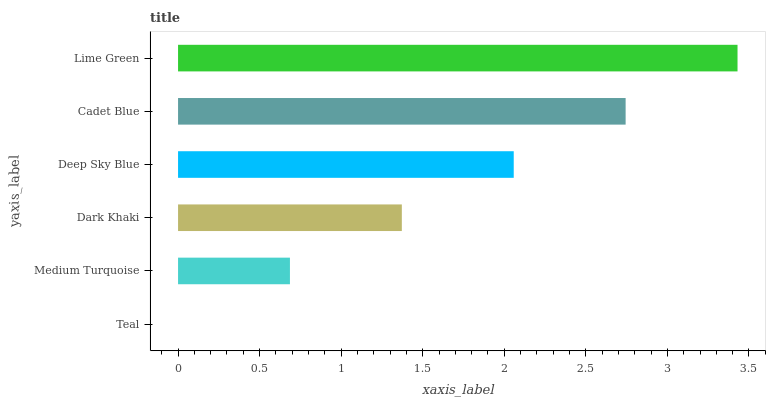Is Teal the minimum?
Answer yes or no. Yes. Is Lime Green the maximum?
Answer yes or no. Yes. Is Medium Turquoise the minimum?
Answer yes or no. No. Is Medium Turquoise the maximum?
Answer yes or no. No. Is Medium Turquoise greater than Teal?
Answer yes or no. Yes. Is Teal less than Medium Turquoise?
Answer yes or no. Yes. Is Teal greater than Medium Turquoise?
Answer yes or no. No. Is Medium Turquoise less than Teal?
Answer yes or no. No. Is Deep Sky Blue the high median?
Answer yes or no. Yes. Is Dark Khaki the low median?
Answer yes or no. Yes. Is Lime Green the high median?
Answer yes or no. No. Is Teal the low median?
Answer yes or no. No. 